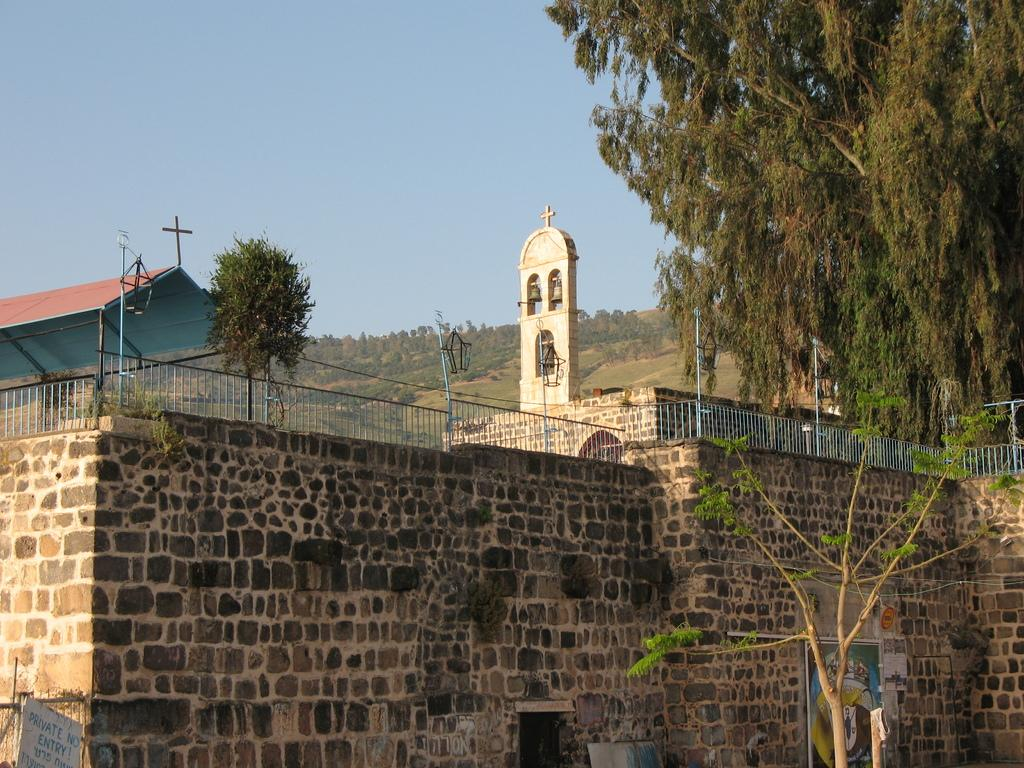What type of building is in the image? There is a church in the image. What other natural elements can be seen in the image? There are trees in the image. What is visible in the background of the image? There is a mountain and the sky in the background of the image. What type of bean is being roasted by the fireman in the image? There is no fireman or bean present in the image. 